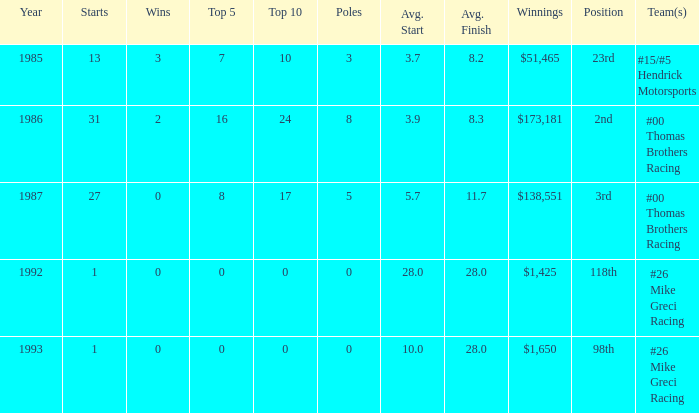On what team did bodine play when his average finish was 8.3? #00 Thomas Brothers Racing. 